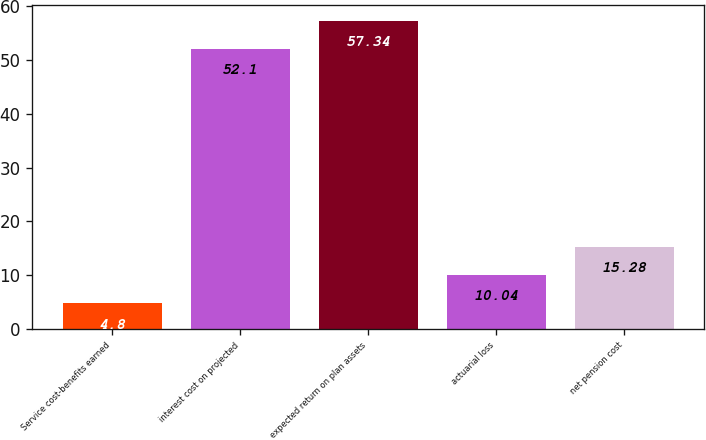Convert chart. <chart><loc_0><loc_0><loc_500><loc_500><bar_chart><fcel>Service cost-benefits earned<fcel>interest cost on projected<fcel>expected return on plan assets<fcel>actuarial loss<fcel>net pension cost<nl><fcel>4.8<fcel>52.1<fcel>57.34<fcel>10.04<fcel>15.28<nl></chart> 